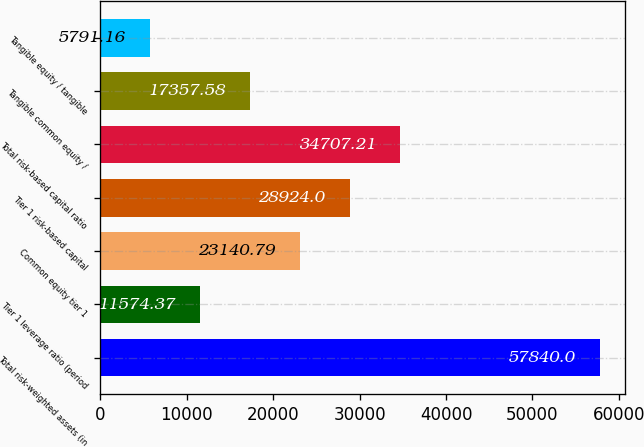Convert chart to OTSL. <chart><loc_0><loc_0><loc_500><loc_500><bar_chart><fcel>Total risk-weighted assets (in<fcel>Tier 1 leverage ratio (period<fcel>Common equity tier 1<fcel>Tier 1 risk-based capital<fcel>Total risk-based capital ratio<fcel>Tangible common equity /<fcel>Tangible equity / tangible<nl><fcel>57840<fcel>11574.4<fcel>23140.8<fcel>28924<fcel>34707.2<fcel>17357.6<fcel>5791.16<nl></chart> 